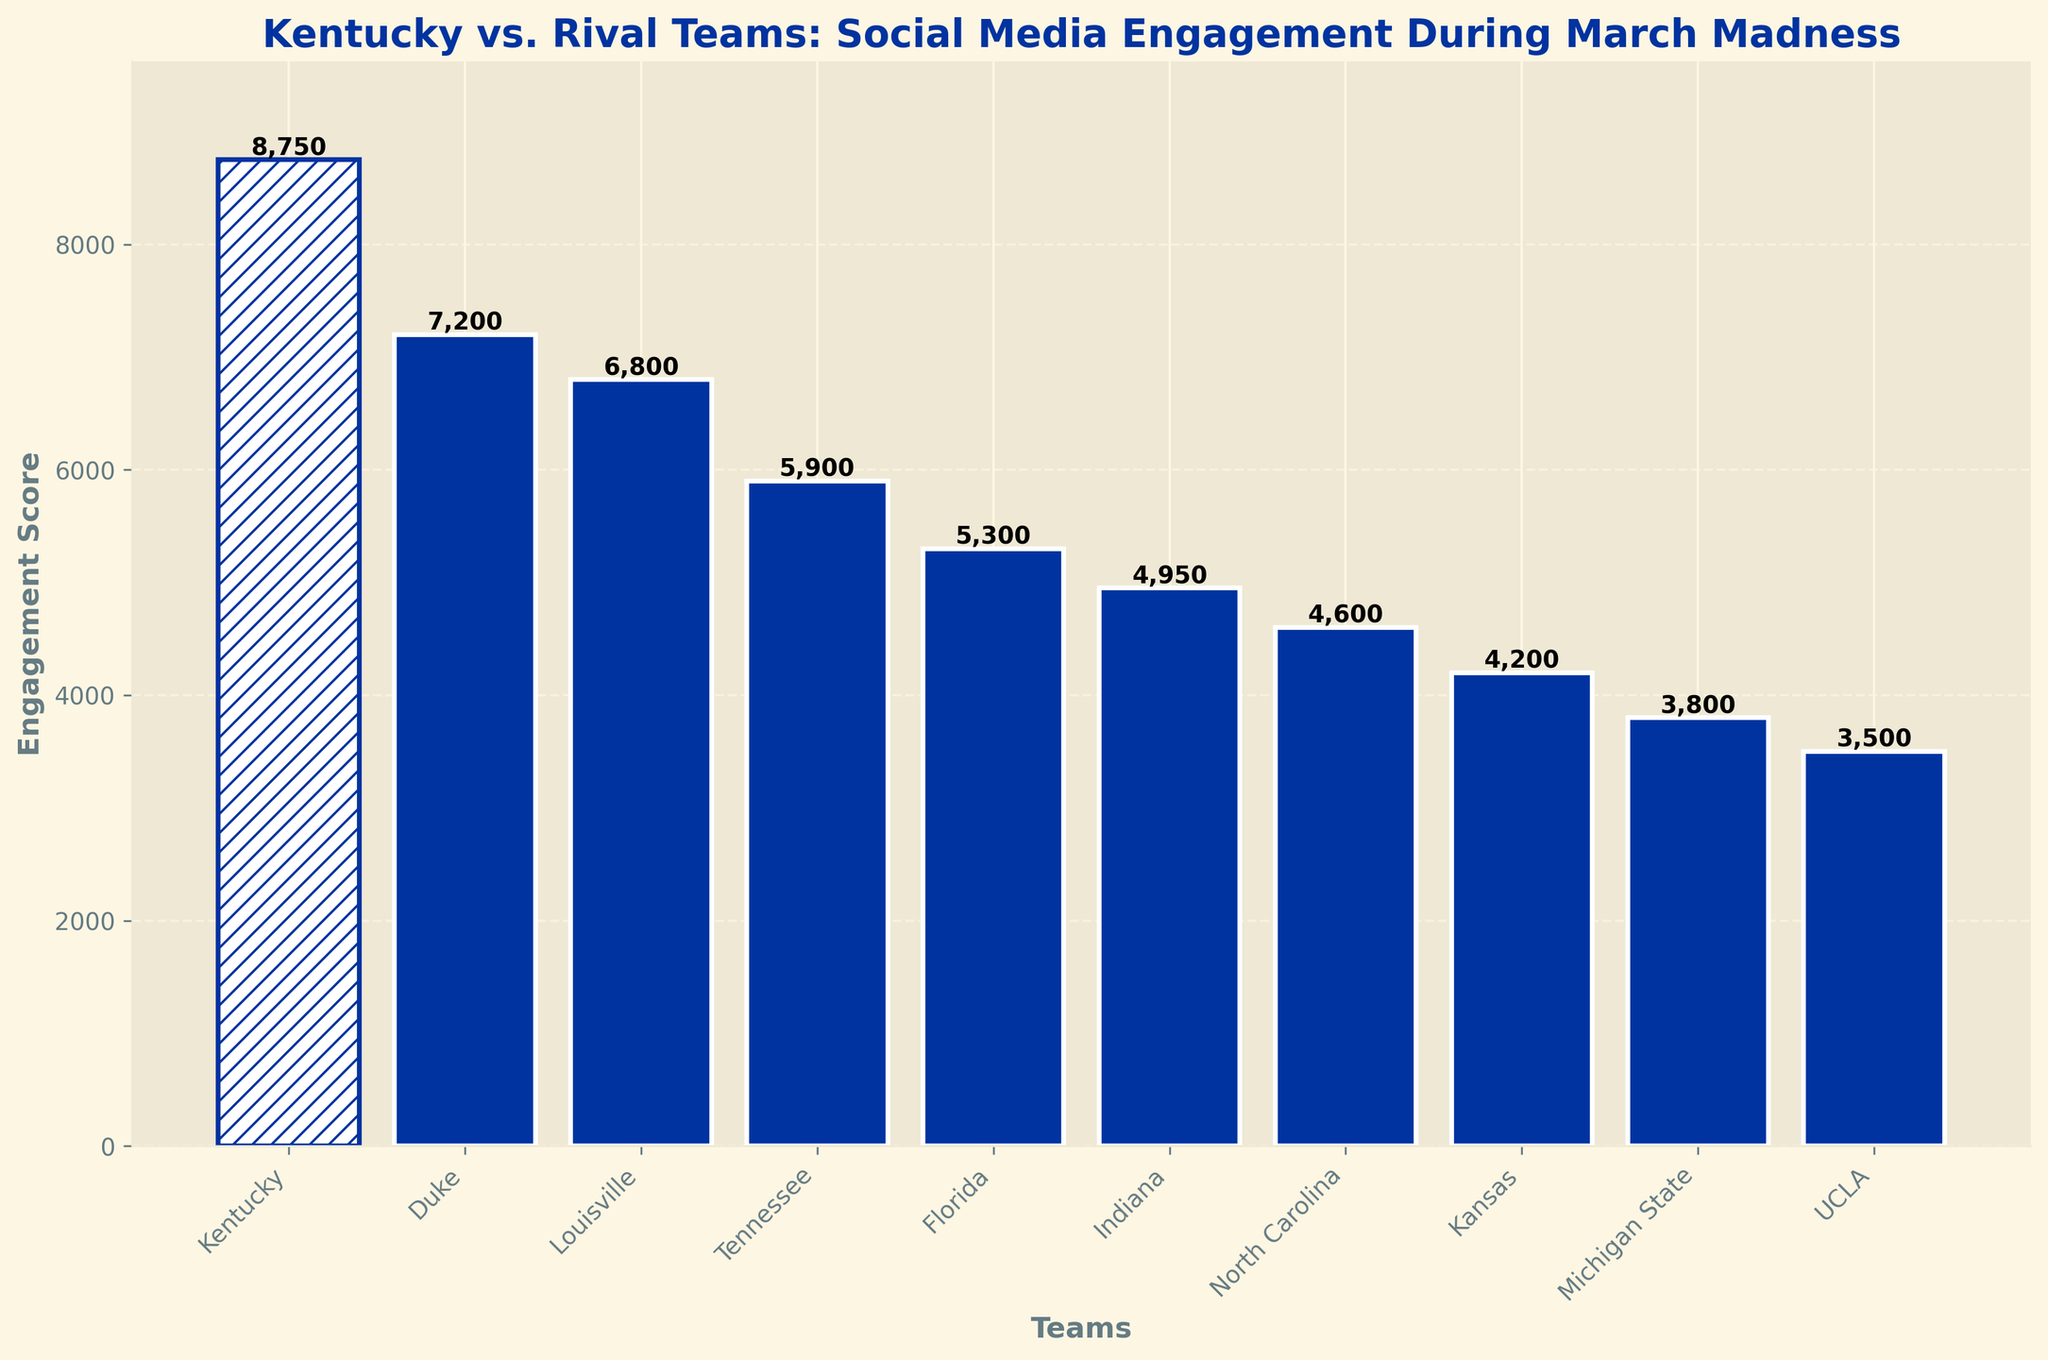Which team has the highest engagement score? Kentucky has the tallest bar with an engagement score of 8750, indicating it has the highest engagement score among the teams.
Answer: Kentucky What's the engagement score difference between Kentucky and Duke? Kentucky's engagement score is 8750 while Duke's is 7200. The difference is 8750 - 7200 = 1550.
Answer: 1550 How does Louisville's engagement score compare to Florida's? Louisville's engagement score is 6800, while Florida's is 5300. 6800 > 5300, so Louisville's score is higher than Florida's.
Answer: Louisville's score is higher Which team has the third-highest engagement score? Kentucky has the highest, Duke has the second-highest, and Louisville has the third-highest engagement score of 6800.
Answer: Louisville Which team has the lowest engagement score? UCLA has the shortest bar with an engagement score of 3500, indicating it has the lowest engagement score among the teams.
Answer: UCLA What is the total engagement score of Tennessee and Florida combined? Tennessee's engagement score is 5900 and Florida's is 5300. The total is 5900 + 5300 = 11200.
Answer: 11200 Which teams have an engagement score above 5000? Kentucky, Duke, Louisville, Tennessee, and Florida all have engagement scores above 5000.
Answer: Kentucky, Duke, Louisville, Tennessee, Florida By how much does Kentucky's engagement score exceed the average engagement score of the other teams? The average engagement score of the other teams is calculated as follows: (7200 + 6800 + 5900 + 5300 + 4950 + 4600 + 4200 + 3800 + 3500)/9 = 5141.11. Kentucky's engagement score exceeds this average by 8750 - 5141.11 = 3608.89.
Answer: 3608.89 Which team between Indiana and Kansas has a higher engagement score? Indiana has an engagement score of 4950 while Kansas has 4200. Indiana's score is higher than Kansas's.
Answer: Indiana 